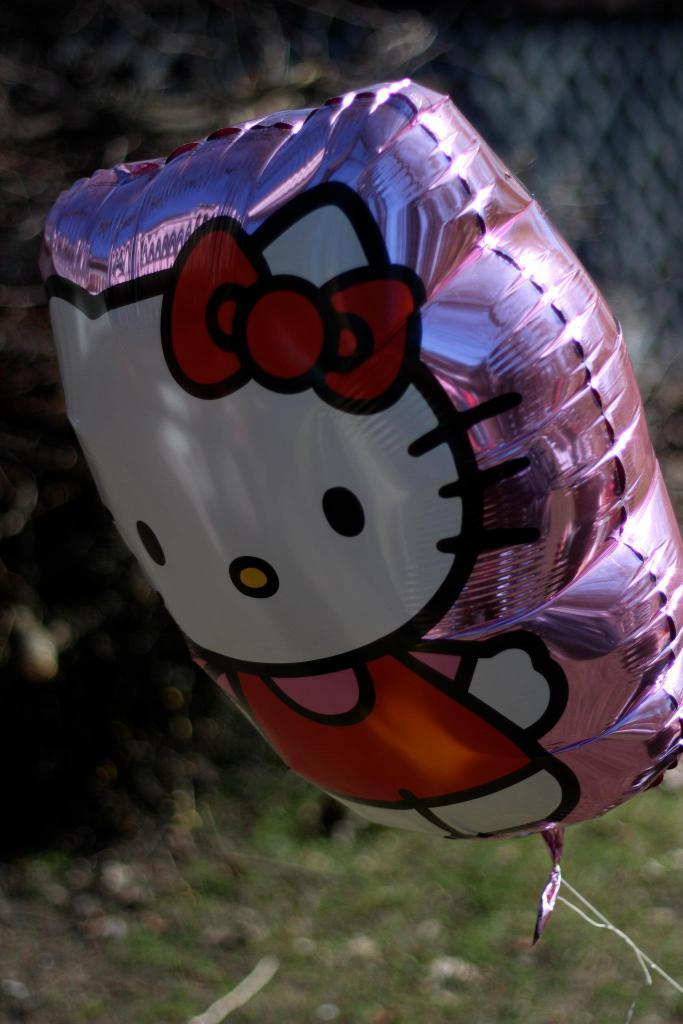What object can be seen floating in the image? There is a balloon present in the image. What type of surface is visible beneath the balloon? There is grass visible in the image. Can you describe the background of the image? The background of the image is blurry. What type of animal can be seen grazing in the background of the image? There are no animals visible in the image; the background is blurry. What type of fuel is required to keep the balloon afloat in the image? The image does not provide information about the type of fuel used to keep the balloon afloat. 